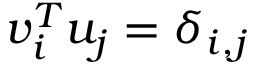Convert formula to latex. <formula><loc_0><loc_0><loc_500><loc_500>v _ { i } ^ { T } u _ { j } = \delta _ { i , j }</formula> 